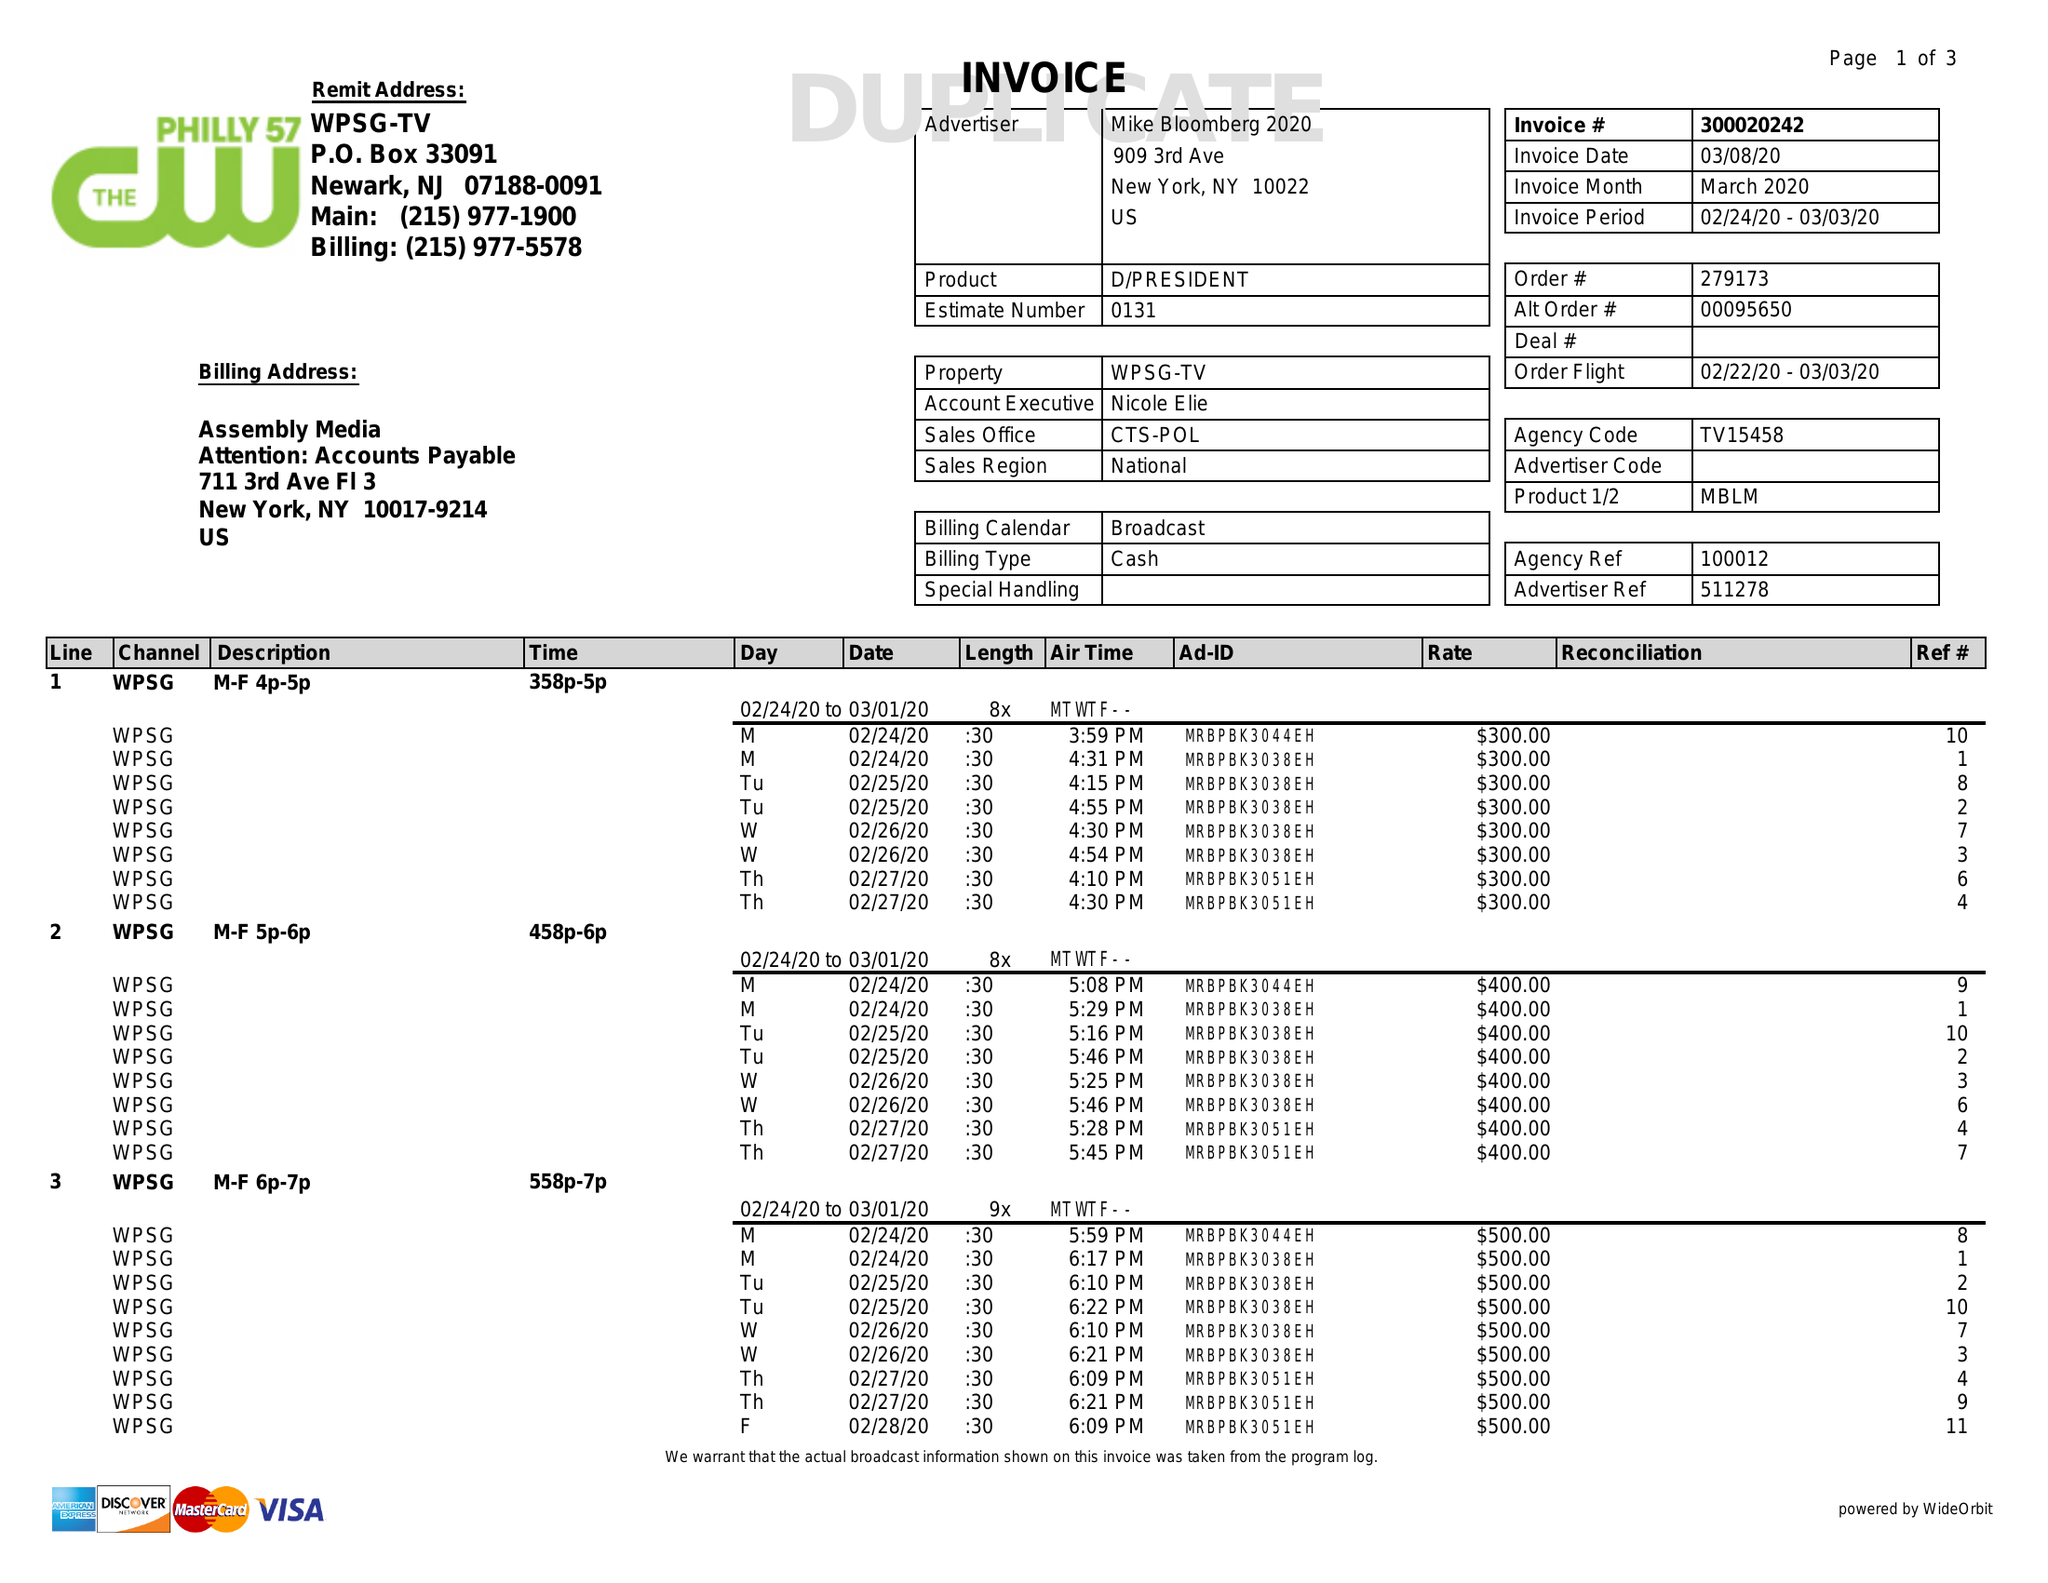What is the value for the advertiser?
Answer the question using a single word or phrase. MIKE BLOOMBERG 2020 